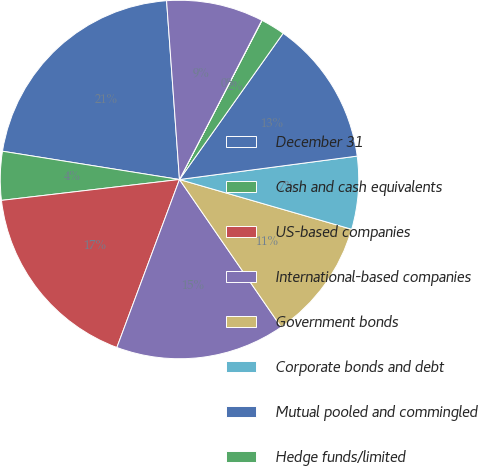<chart> <loc_0><loc_0><loc_500><loc_500><pie_chart><fcel>December 31<fcel>Cash and cash equivalents<fcel>US-based companies<fcel>International-based companies<fcel>Government bonds<fcel>Corporate bonds and debt<fcel>Mutual pooled and commingled<fcel>Hedge funds/limited<fcel>Real estate<fcel>Other<nl><fcel>21.33%<fcel>4.38%<fcel>17.46%<fcel>15.28%<fcel>10.92%<fcel>6.56%<fcel>13.1%<fcel>2.2%<fcel>0.02%<fcel>8.74%<nl></chart> 